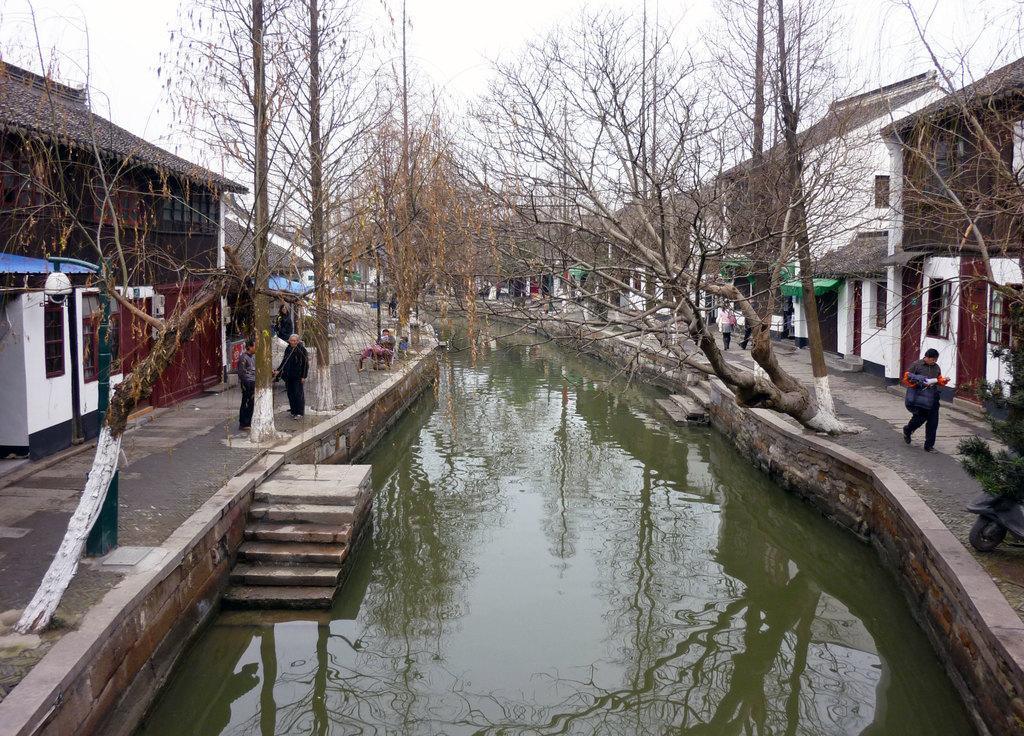Please provide a concise description of this image. In this image I see the path on which there are few people and I see the water over here and I see the steps and I can also see the trees and I see a light pole over here and I see number of buildings. In the background I see the sky. 